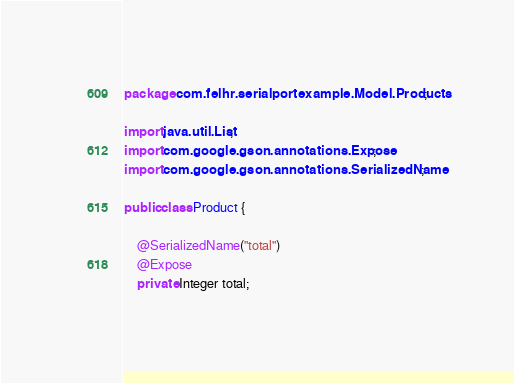Convert code to text. <code><loc_0><loc_0><loc_500><loc_500><_Java_>
package com.felhr.serialportexample.Model.Products;

import java.util.List;
import com.google.gson.annotations.Expose;
import com.google.gson.annotations.SerializedName;

public class Product {

    @SerializedName("total")
    @Expose
    private Integer total;</code> 